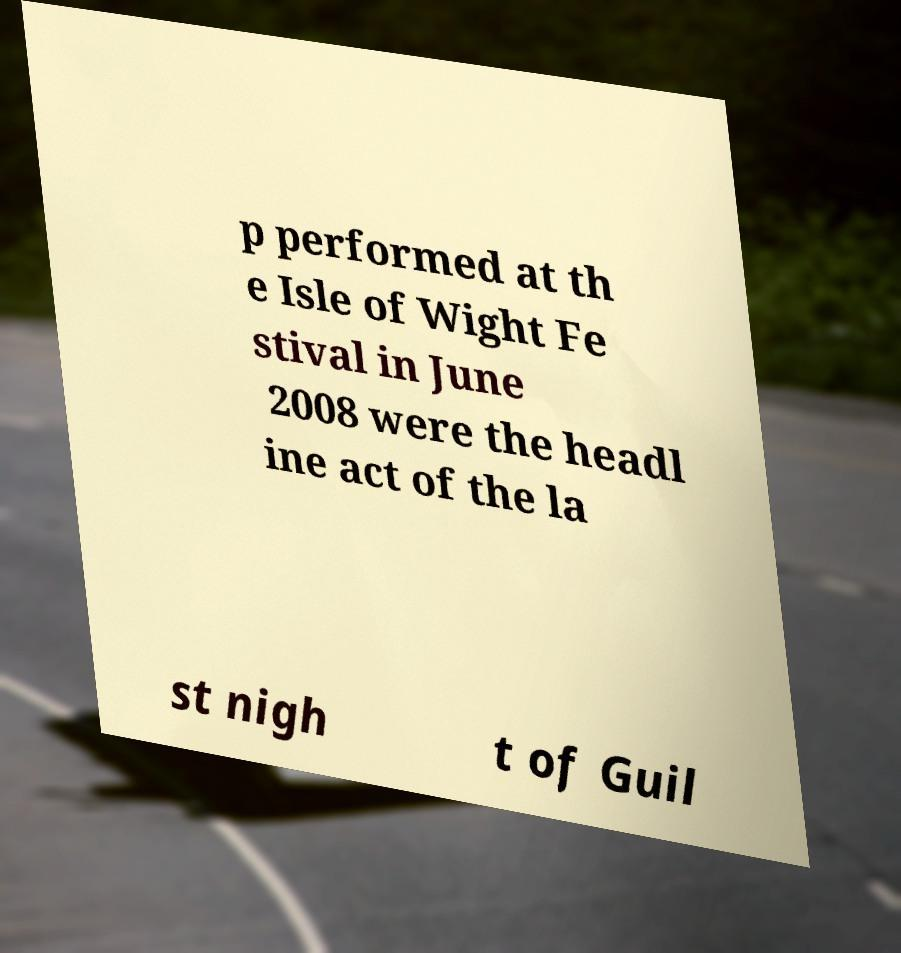What messages or text are displayed in this image? I need them in a readable, typed format. p performed at th e Isle of Wight Fe stival in June 2008 were the headl ine act of the la st nigh t of Guil 